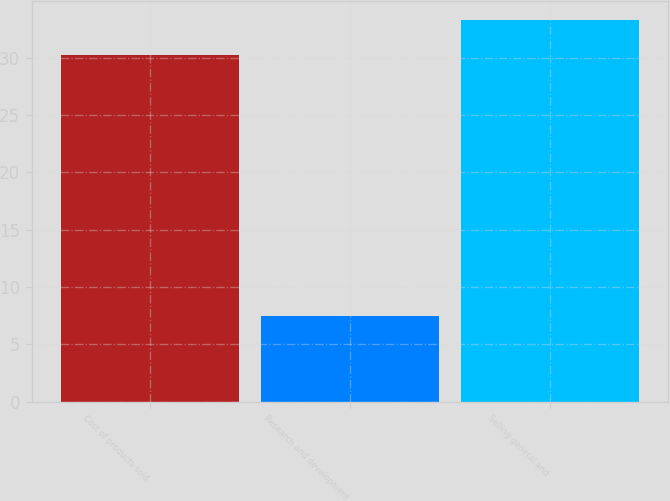<chart> <loc_0><loc_0><loc_500><loc_500><bar_chart><fcel>Cost of products sold<fcel>Research and development<fcel>Selling general and<nl><fcel>30.2<fcel>7.5<fcel>33.3<nl></chart> 